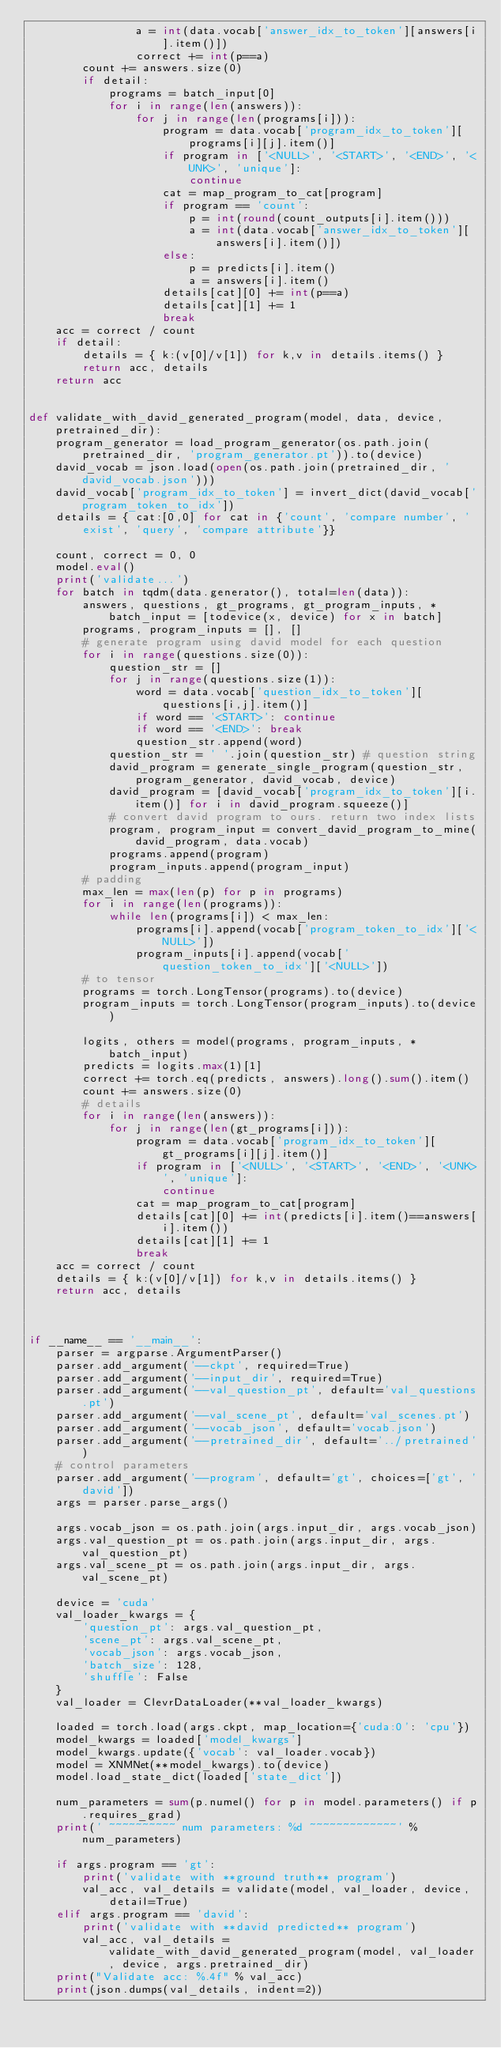Convert code to text. <code><loc_0><loc_0><loc_500><loc_500><_Python_>                a = int(data.vocab['answer_idx_to_token'][answers[i].item()])
                correct += int(p==a)
        count += answers.size(0)
        if detail:
            programs = batch_input[0]
            for i in range(len(answers)):
                for j in range(len(programs[i])):
                    program = data.vocab['program_idx_to_token'][programs[i][j].item()]
                    if program in ['<NULL>', '<START>', '<END>', '<UNK>', 'unique']:
                        continue
                    cat = map_program_to_cat[program]
                    if program == 'count':
                        p = int(round(count_outputs[i].item()))
                        a = int(data.vocab['answer_idx_to_token'][answers[i].item()])
                    else:
                        p = predicts[i].item()
                        a = answers[i].item()
                    details[cat][0] += int(p==a)
                    details[cat][1] += 1
                    break
    acc = correct / count
    if detail:
        details = { k:(v[0]/v[1]) for k,v in details.items() }
        return acc, details
    return acc


def validate_with_david_generated_program(model, data, device, pretrained_dir):
    program_generator = load_program_generator(os.path.join(pretrained_dir, 'program_generator.pt')).to(device)
    david_vocab = json.load(open(os.path.join(pretrained_dir, 'david_vocab.json')))
    david_vocab['program_idx_to_token'] = invert_dict(david_vocab['program_token_to_idx'])
    details = { cat:[0,0] for cat in {'count', 'compare number', 'exist', 'query', 'compare attribute'}}

    count, correct = 0, 0
    model.eval()
    print('validate...')
    for batch in tqdm(data.generator(), total=len(data)):
        answers, questions, gt_programs, gt_program_inputs, *batch_input = [todevice(x, device) for x in batch]
        programs, program_inputs = [], []
        # generate program using david model for each question
        for i in range(questions.size(0)):
            question_str = []
            for j in range(questions.size(1)):
                word = data.vocab['question_idx_to_token'][questions[i,j].item()]
                if word == '<START>': continue
                if word == '<END>': break
                question_str.append(word)
            question_str = ' '.join(question_str) # question string
            david_program = generate_single_program(question_str, program_generator, david_vocab, device)
            david_program = [david_vocab['program_idx_to_token'][i.item()] for i in david_program.squeeze()]
            # convert david program to ours. return two index lists
            program, program_input = convert_david_program_to_mine(david_program, data.vocab)
            programs.append(program)
            program_inputs.append(program_input)
        # padding
        max_len = max(len(p) for p in programs)
        for i in range(len(programs)):
            while len(programs[i]) < max_len:
                programs[i].append(vocab['program_token_to_idx']['<NULL>'])
                program_inputs[i].append(vocab['question_token_to_idx']['<NULL>'])
        # to tensor
        programs = torch.LongTensor(programs).to(device)
        program_inputs = torch.LongTensor(program_inputs).to(device)

        logits, others = model(programs, program_inputs, *batch_input)
        predicts = logits.max(1)[1]
        correct += torch.eq(predicts, answers).long().sum().item()
        count += answers.size(0)
        # details
        for i in range(len(answers)):
            for j in range(len(gt_programs[i])):
                program = data.vocab['program_idx_to_token'][gt_programs[i][j].item()]
                if program in ['<NULL>', '<START>', '<END>', '<UNK>', 'unique']:
                    continue
                cat = map_program_to_cat[program]
                details[cat][0] += int(predicts[i].item()==answers[i].item())
                details[cat][1] += 1
                break
    acc = correct / count
    details = { k:(v[0]/v[1]) for k,v in details.items() }
    return acc, details



if __name__ == '__main__':
    parser = argparse.ArgumentParser()
    parser.add_argument('--ckpt', required=True)
    parser.add_argument('--input_dir', required=True)
    parser.add_argument('--val_question_pt', default='val_questions.pt')
    parser.add_argument('--val_scene_pt', default='val_scenes.pt')
    parser.add_argument('--vocab_json', default='vocab.json')
    parser.add_argument('--pretrained_dir', default='../pretrained')
    # control parameters
    parser.add_argument('--program', default='gt', choices=['gt', 'david'])
    args = parser.parse_args()

    args.vocab_json = os.path.join(args.input_dir, args.vocab_json)
    args.val_question_pt = os.path.join(args.input_dir, args.val_question_pt)
    args.val_scene_pt = os.path.join(args.input_dir, args.val_scene_pt)
    
    device = 'cuda'
    val_loader_kwargs = {
        'question_pt': args.val_question_pt,
        'scene_pt': args.val_scene_pt,
        'vocab_json': args.vocab_json,
        'batch_size': 128,
        'shuffle': False
    }
    val_loader = ClevrDataLoader(**val_loader_kwargs)
    
    loaded = torch.load(args.ckpt, map_location={'cuda:0': 'cpu'})
    model_kwargs = loaded['model_kwargs']
    model_kwargs.update({'vocab': val_loader.vocab})
    model = XNMNet(**model_kwargs).to(device)
    model.load_state_dict(loaded['state_dict'])

    num_parameters = sum(p.numel() for p in model.parameters() if p.requires_grad)
    print(' ~~~~~~~~~~ num parameters: %d ~~~~~~~~~~~~~' % num_parameters)

    if args.program == 'gt':
        print('validate with **ground truth** program')
        val_acc, val_details = validate(model, val_loader, device, detail=True)
    elif args.program == 'david':
        print('validate with **david predicted** program')
        val_acc, val_details = validate_with_david_generated_program(model, val_loader, device, args.pretrained_dir)
    print("Validate acc: %.4f" % val_acc)
    print(json.dumps(val_details, indent=2))
</code> 